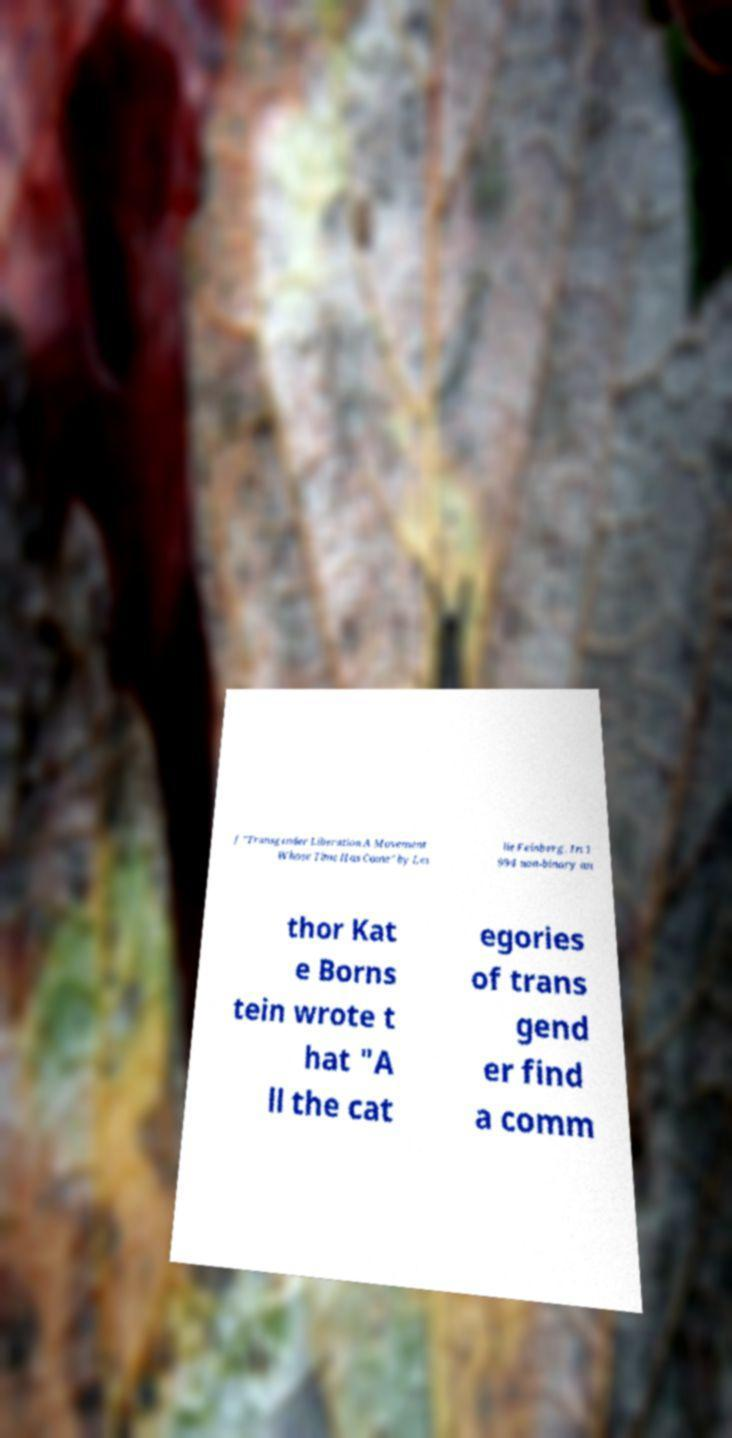I need the written content from this picture converted into text. Can you do that? f "Transgender Liberation A Movement Whose Time Has Come" by Les lie Feinberg. In 1 994 non-binary au thor Kat e Borns tein wrote t hat "A ll the cat egories of trans gend er find a comm 